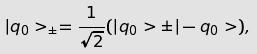<formula> <loc_0><loc_0><loc_500><loc_500>| q _ { 0 } > _ { \pm } = \frac { 1 } { \sqrt { 2 } } ( | q _ { 0 } > \pm | - q _ { 0 } > ) ,</formula> 